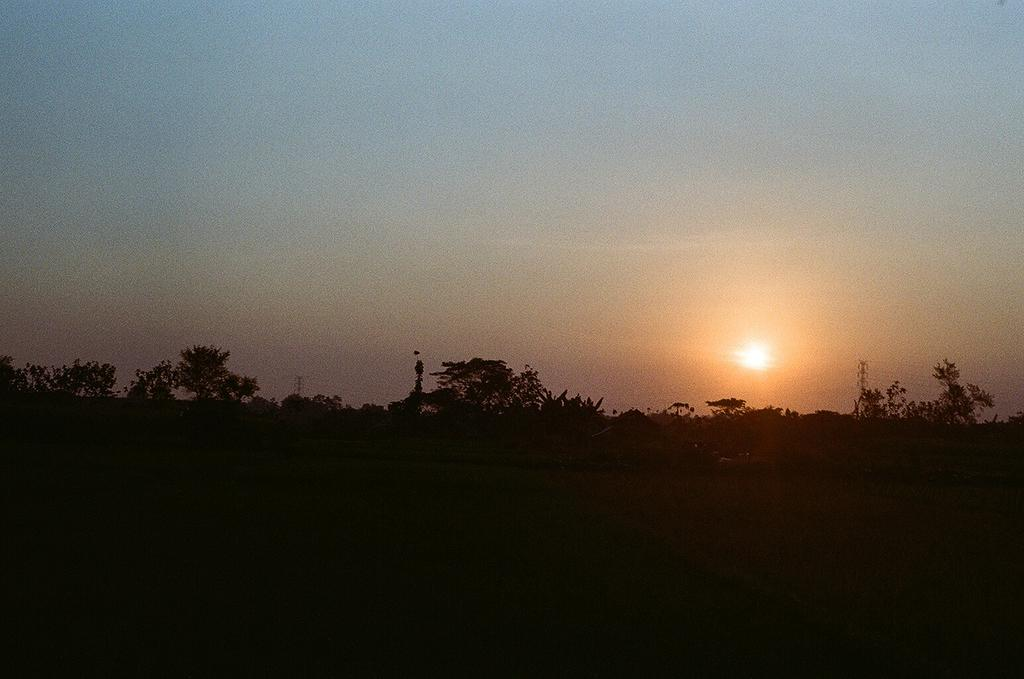What can be observed at the bottom of the image? The bottom of the image is dark. What is located in the middle of the image? There are trees, sunlight, and objects in the middle of the image. Can you describe the objects in the middle of the image? Unfortunately, the provided facts do not specify the nature of the objects in the image. What is visible at the top of the image? The sky is visible at the top of the image. Can you tell me how many legs are visible in the image? There is no mention of legs or any leg-like objects in the provided facts, so it is impossible to determine the number of legs visible in the image. 